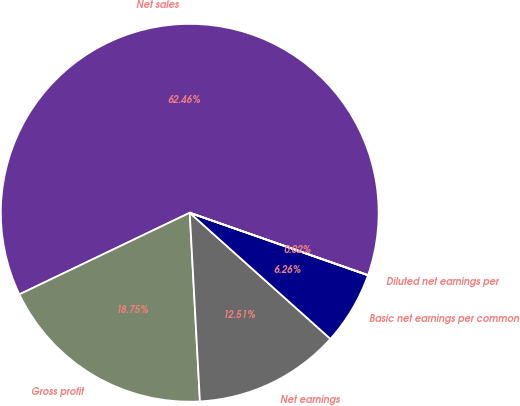Convert chart to OTSL. <chart><loc_0><loc_0><loc_500><loc_500><pie_chart><fcel>Net sales<fcel>Gross profit<fcel>Net earnings<fcel>Basic net earnings per common<fcel>Diluted net earnings per<nl><fcel>62.46%<fcel>18.75%<fcel>12.51%<fcel>6.26%<fcel>0.02%<nl></chart> 